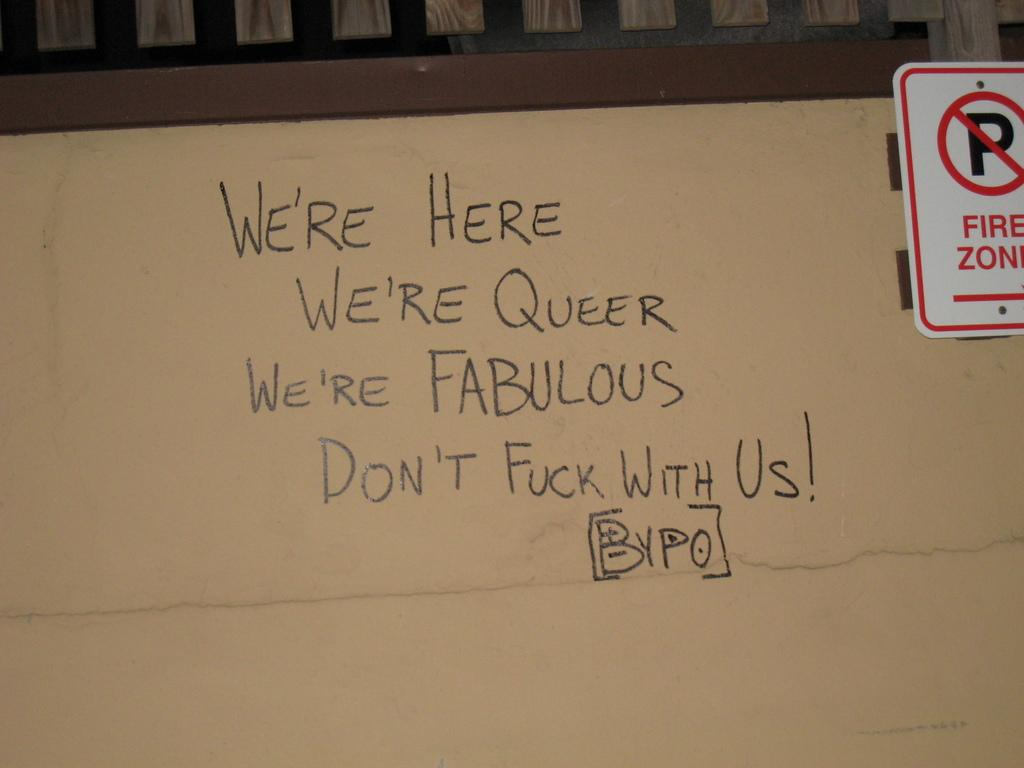<image>
Provide a brief description of the given image. We're Here along with a few other chosen words is displayed along with a no parking fire zone sign 